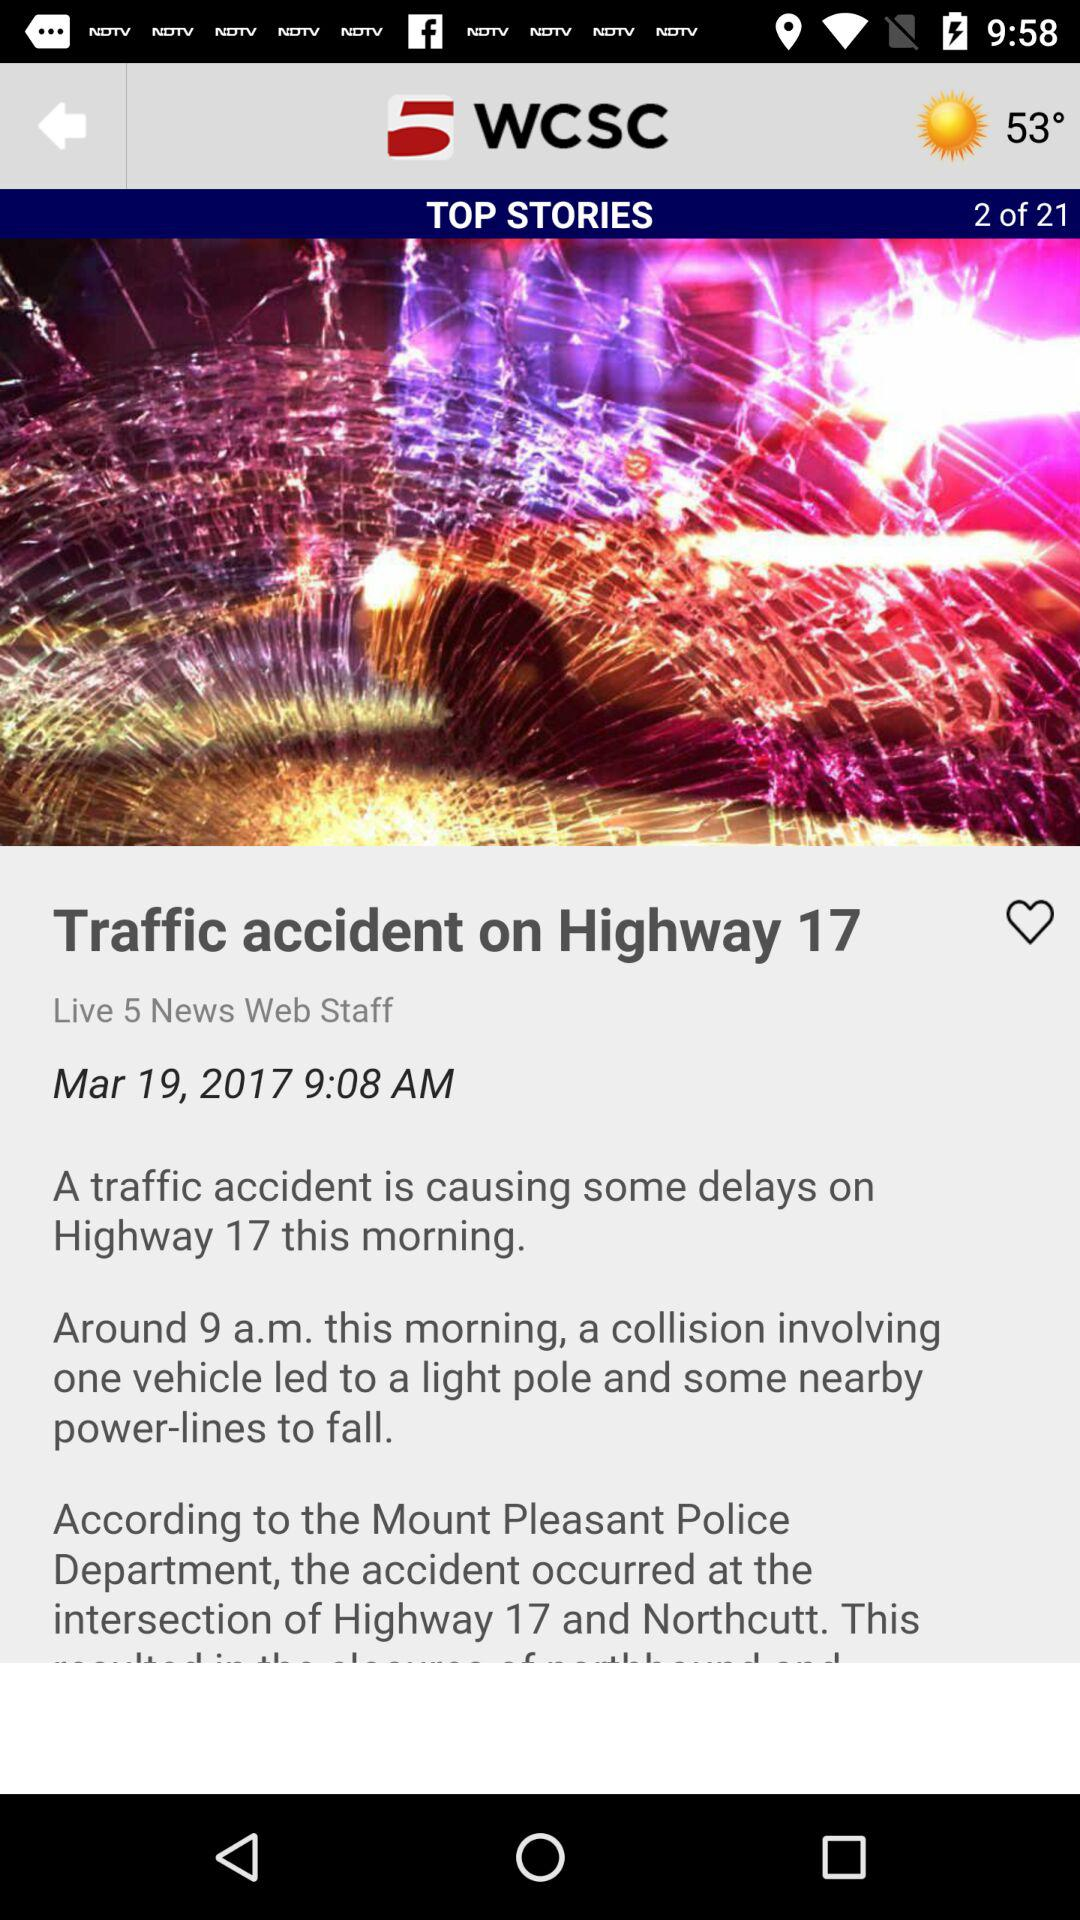How many reviews does this top story have?
When the provided information is insufficient, respond with <no answer>. <no answer> 